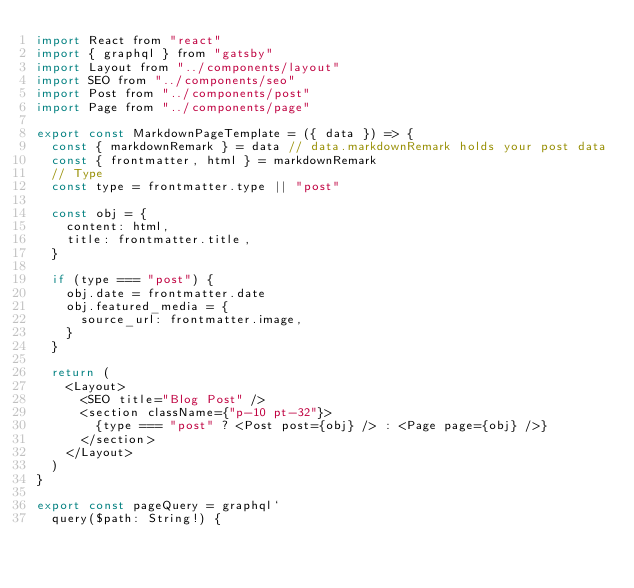<code> <loc_0><loc_0><loc_500><loc_500><_JavaScript_>import React from "react"
import { graphql } from "gatsby"
import Layout from "../components/layout"
import SEO from "../components/seo"
import Post from "../components/post"
import Page from "../components/page"

export const MarkdownPageTemplate = ({ data }) => {
  const { markdownRemark } = data // data.markdownRemark holds your post data
  const { frontmatter, html } = markdownRemark
  // Type
  const type = frontmatter.type || "post"

  const obj = {
    content: html,
    title: frontmatter.title,
  }

  if (type === "post") {
    obj.date = frontmatter.date
    obj.featured_media = {
      source_url: frontmatter.image,
    }
  }

  return (
    <Layout>
      <SEO title="Blog Post" />
      <section className={"p-10 pt-32"}>
        {type === "post" ? <Post post={obj} /> : <Page page={obj} />}
      </section>
    </Layout>
  )
}

export const pageQuery = graphql`
  query($path: String!) {</code> 